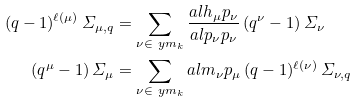<formula> <loc_0><loc_0><loc_500><loc_500>( q - 1 ) ^ { \ell ( \mu ) } \, \varSigma _ { \mu , q } & = \sum _ { \nu \in \ y m _ { k } } \frac { a l { h _ { \mu } } { p _ { \nu } } } { a l { p _ { \nu } } { p _ { \nu } } } \, ( q ^ { \nu } - 1 ) \, \varSigma _ { \nu } \\ ( q ^ { \mu } - 1 ) \, \varSigma _ { \mu } & = \sum _ { \nu \in \ y m _ { k } } a l { m _ { \nu } } { p _ { \mu } } \, ( q - 1 ) ^ { \ell ( \nu ) } \, \varSigma _ { \nu , q }</formula> 